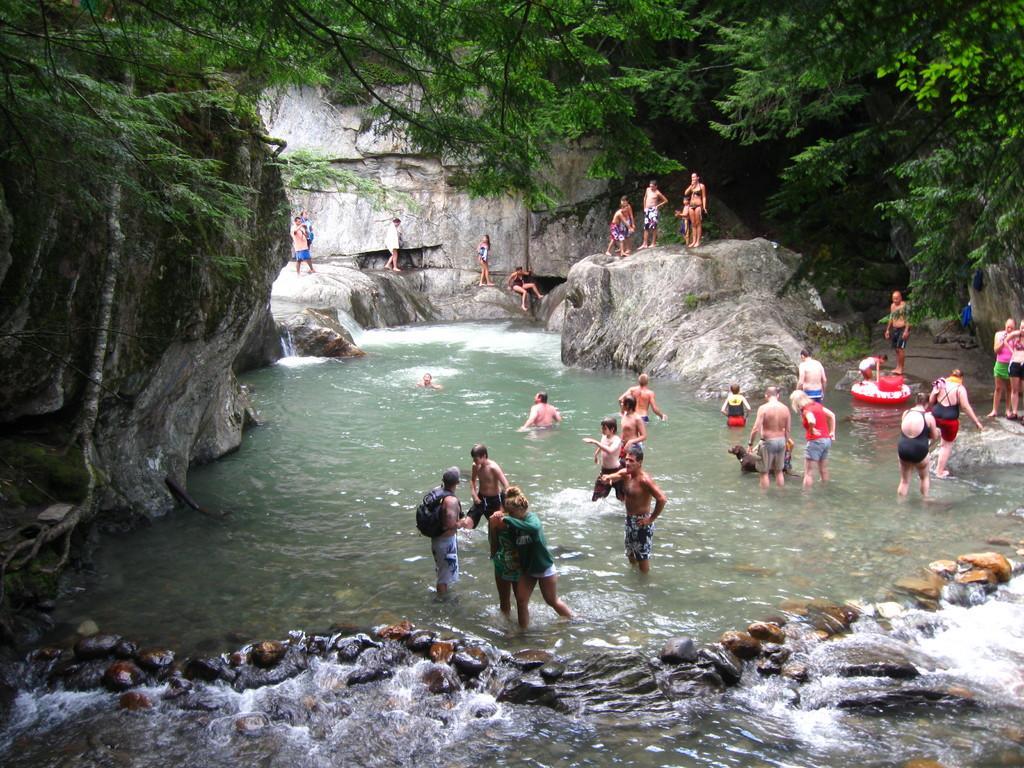Can you describe this image briefly? In this image we can see people standing in the water and some are standing on the rocks. In the background there are rocks, trees and stones. 